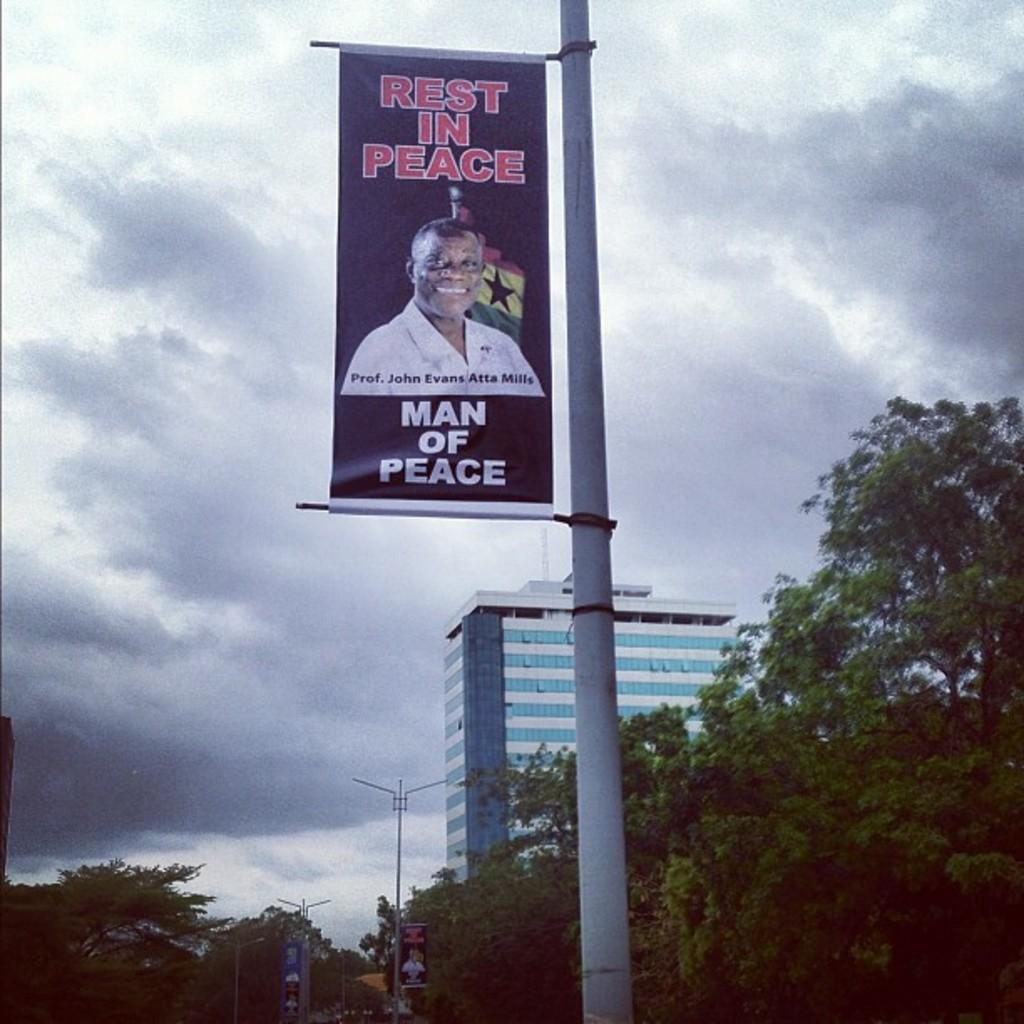He was a man of ?
Your answer should be very brief. Peace. Who died according to this banner?
Your response must be concise. Prof. john evans atta mills. 